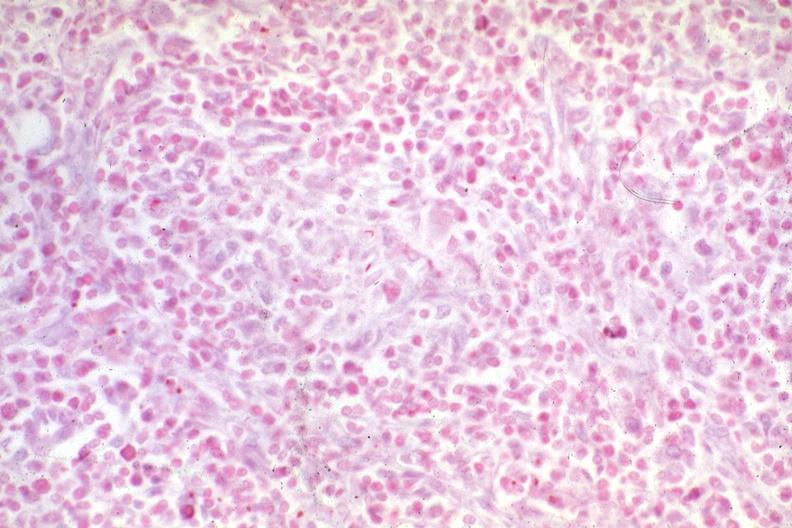s lymph node present?
Answer the question using a single word or phrase. Yes 